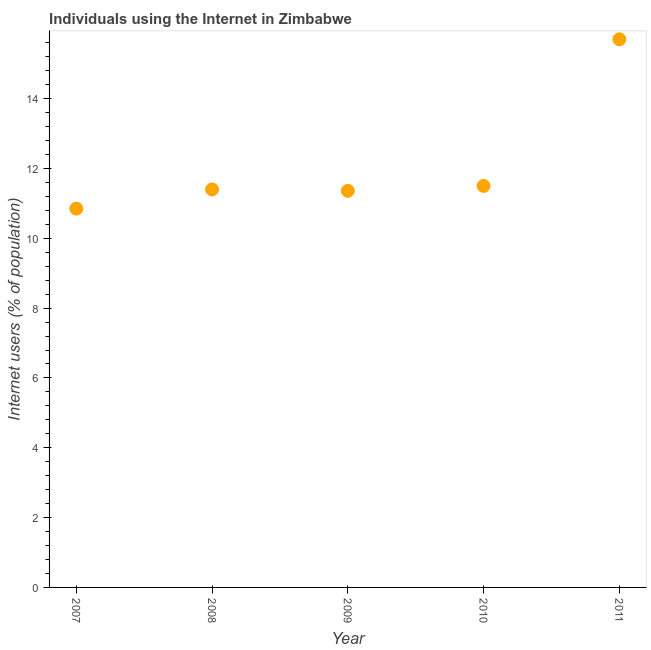What is the number of internet users in 2008?
Provide a short and direct response. 11.4. Across all years, what is the minimum number of internet users?
Make the answer very short. 10.85. What is the sum of the number of internet users?
Offer a terse response. 60.81. What is the difference between the number of internet users in 2010 and 2011?
Make the answer very short. -4.2. What is the average number of internet users per year?
Make the answer very short. 12.16. What is the median number of internet users?
Offer a very short reply. 11.4. In how many years, is the number of internet users greater than 2 %?
Keep it short and to the point. 5. Do a majority of the years between 2007 and 2011 (inclusive) have number of internet users greater than 9.2 %?
Give a very brief answer. Yes. What is the ratio of the number of internet users in 2007 to that in 2010?
Keep it short and to the point. 0.94. Is the number of internet users in 2010 less than that in 2011?
Keep it short and to the point. Yes. Is the difference between the number of internet users in 2010 and 2011 greater than the difference between any two years?
Keep it short and to the point. No. What is the difference between the highest and the second highest number of internet users?
Your answer should be compact. 4.2. Is the sum of the number of internet users in 2007 and 2011 greater than the maximum number of internet users across all years?
Ensure brevity in your answer.  Yes. What is the difference between the highest and the lowest number of internet users?
Your response must be concise. 4.85. How many dotlines are there?
Provide a succinct answer. 1. What is the difference between two consecutive major ticks on the Y-axis?
Your answer should be compact. 2. Does the graph contain any zero values?
Make the answer very short. No. What is the title of the graph?
Your answer should be very brief. Individuals using the Internet in Zimbabwe. What is the label or title of the X-axis?
Ensure brevity in your answer.  Year. What is the label or title of the Y-axis?
Provide a succinct answer. Internet users (% of population). What is the Internet users (% of population) in 2007?
Ensure brevity in your answer.  10.85. What is the Internet users (% of population) in 2009?
Offer a terse response. 11.36. What is the Internet users (% of population) in 2011?
Provide a short and direct response. 15.7. What is the difference between the Internet users (% of population) in 2007 and 2008?
Provide a short and direct response. -0.55. What is the difference between the Internet users (% of population) in 2007 and 2009?
Ensure brevity in your answer.  -0.51. What is the difference between the Internet users (% of population) in 2007 and 2010?
Offer a very short reply. -0.65. What is the difference between the Internet users (% of population) in 2007 and 2011?
Your answer should be compact. -4.85. What is the difference between the Internet users (% of population) in 2008 and 2009?
Keep it short and to the point. 0.04. What is the difference between the Internet users (% of population) in 2008 and 2010?
Provide a succinct answer. -0.1. What is the difference between the Internet users (% of population) in 2008 and 2011?
Your response must be concise. -4.3. What is the difference between the Internet users (% of population) in 2009 and 2010?
Provide a short and direct response. -0.14. What is the difference between the Internet users (% of population) in 2009 and 2011?
Give a very brief answer. -4.34. What is the ratio of the Internet users (% of population) in 2007 to that in 2009?
Offer a very short reply. 0.95. What is the ratio of the Internet users (% of population) in 2007 to that in 2010?
Your response must be concise. 0.94. What is the ratio of the Internet users (% of population) in 2007 to that in 2011?
Ensure brevity in your answer.  0.69. What is the ratio of the Internet users (% of population) in 2008 to that in 2011?
Ensure brevity in your answer.  0.73. What is the ratio of the Internet users (% of population) in 2009 to that in 2010?
Your answer should be compact. 0.99. What is the ratio of the Internet users (% of population) in 2009 to that in 2011?
Provide a short and direct response. 0.72. What is the ratio of the Internet users (% of population) in 2010 to that in 2011?
Offer a very short reply. 0.73. 